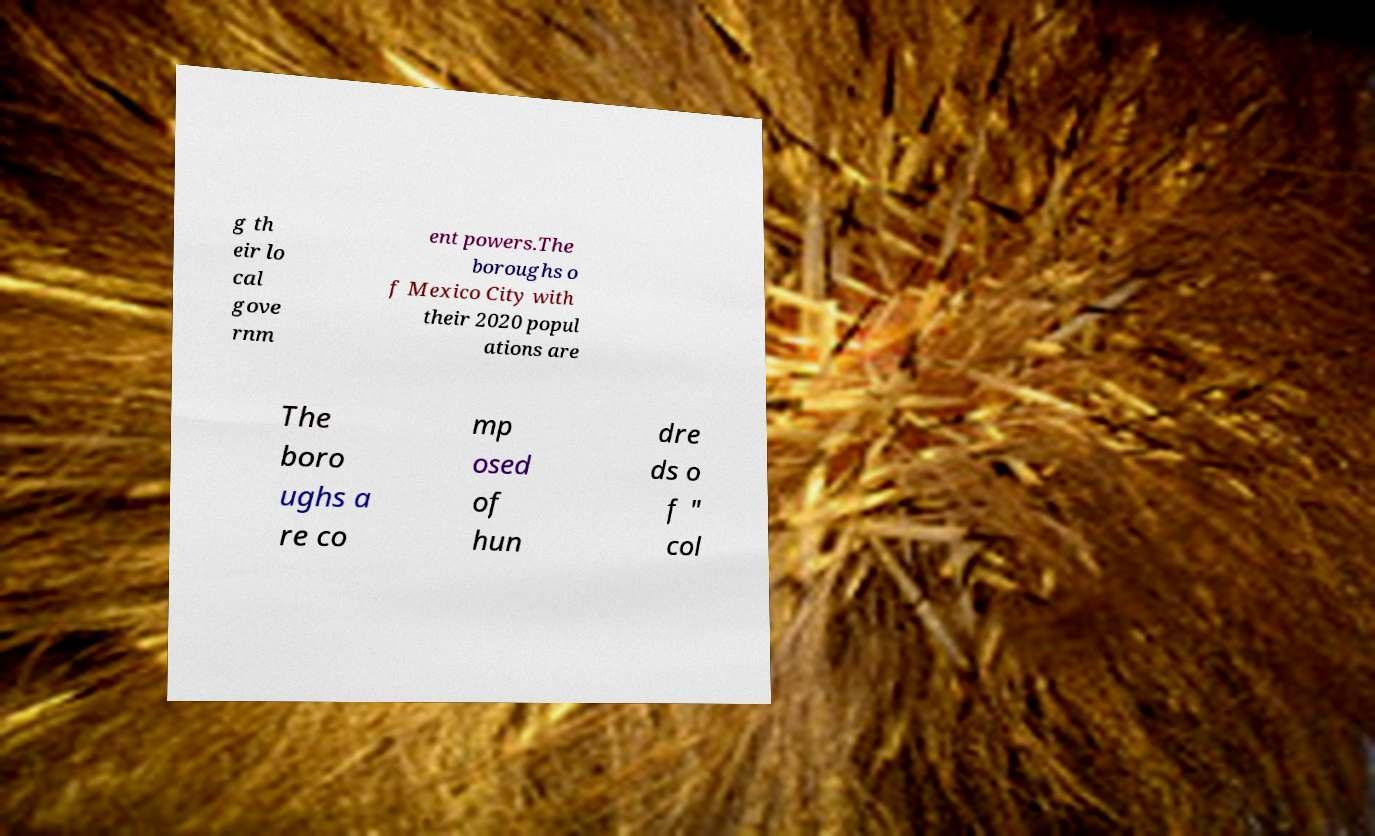For documentation purposes, I need the text within this image transcribed. Could you provide that? g th eir lo cal gove rnm ent powers.The boroughs o f Mexico City with their 2020 popul ations are The boro ughs a re co mp osed of hun dre ds o f " col 